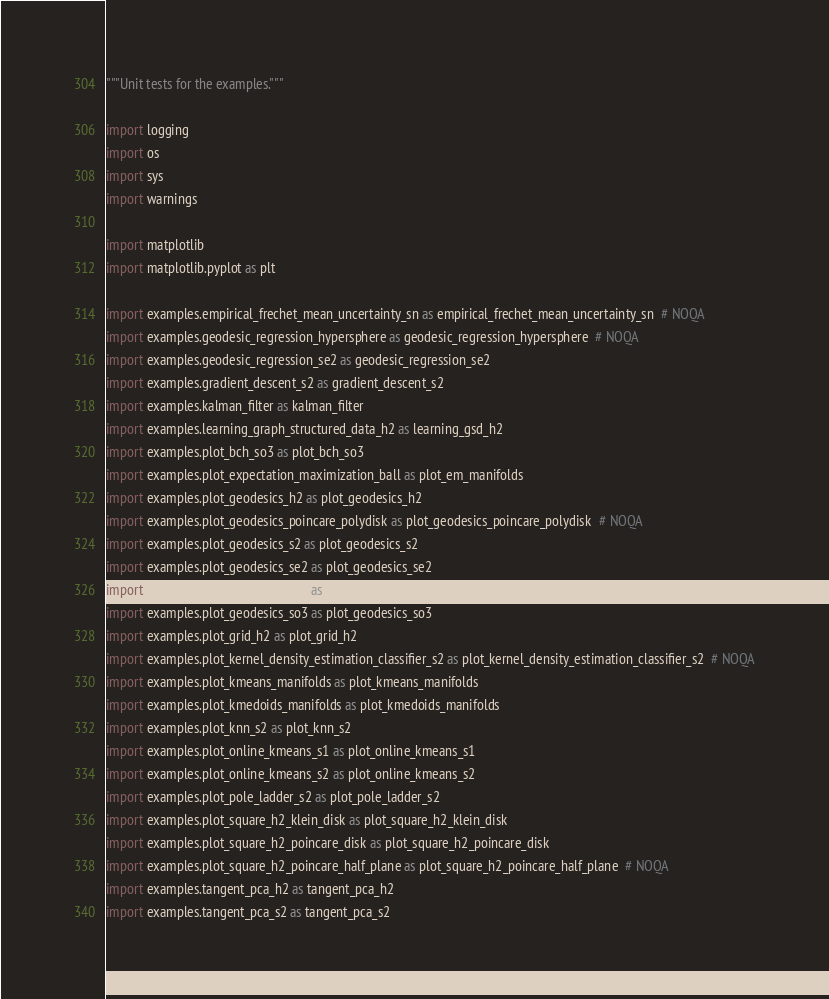Convert code to text. <code><loc_0><loc_0><loc_500><loc_500><_Python_>"""Unit tests for the examples."""

import logging
import os
import sys
import warnings

import matplotlib
import matplotlib.pyplot as plt

import examples.empirical_frechet_mean_uncertainty_sn as empirical_frechet_mean_uncertainty_sn  # NOQA
import examples.geodesic_regression_hypersphere as geodesic_regression_hypersphere  # NOQA
import examples.geodesic_regression_se2 as geodesic_regression_se2
import examples.gradient_descent_s2 as gradient_descent_s2
import examples.kalman_filter as kalman_filter
import examples.learning_graph_structured_data_h2 as learning_gsd_h2
import examples.plot_bch_so3 as plot_bch_so3
import examples.plot_expectation_maximization_ball as plot_em_manifolds
import examples.plot_geodesics_h2 as plot_geodesics_h2
import examples.plot_geodesics_poincare_polydisk as plot_geodesics_poincare_polydisk  # NOQA
import examples.plot_geodesics_s2 as plot_geodesics_s2
import examples.plot_geodesics_se2 as plot_geodesics_se2
import examples.plot_geodesics_se3 as plot_geodesics_se3
import examples.plot_geodesics_so3 as plot_geodesics_so3
import examples.plot_grid_h2 as plot_grid_h2
import examples.plot_kernel_density_estimation_classifier_s2 as plot_kernel_density_estimation_classifier_s2  # NOQA
import examples.plot_kmeans_manifolds as plot_kmeans_manifolds
import examples.plot_kmedoids_manifolds as plot_kmedoids_manifolds
import examples.plot_knn_s2 as plot_knn_s2
import examples.plot_online_kmeans_s1 as plot_online_kmeans_s1
import examples.plot_online_kmeans_s2 as plot_online_kmeans_s2
import examples.plot_pole_ladder_s2 as plot_pole_ladder_s2
import examples.plot_square_h2_klein_disk as plot_square_h2_klein_disk
import examples.plot_square_h2_poincare_disk as plot_square_h2_poincare_disk
import examples.plot_square_h2_poincare_half_plane as plot_square_h2_poincare_half_plane  # NOQA
import examples.tangent_pca_h2 as tangent_pca_h2
import examples.tangent_pca_s2 as tangent_pca_s2</code> 